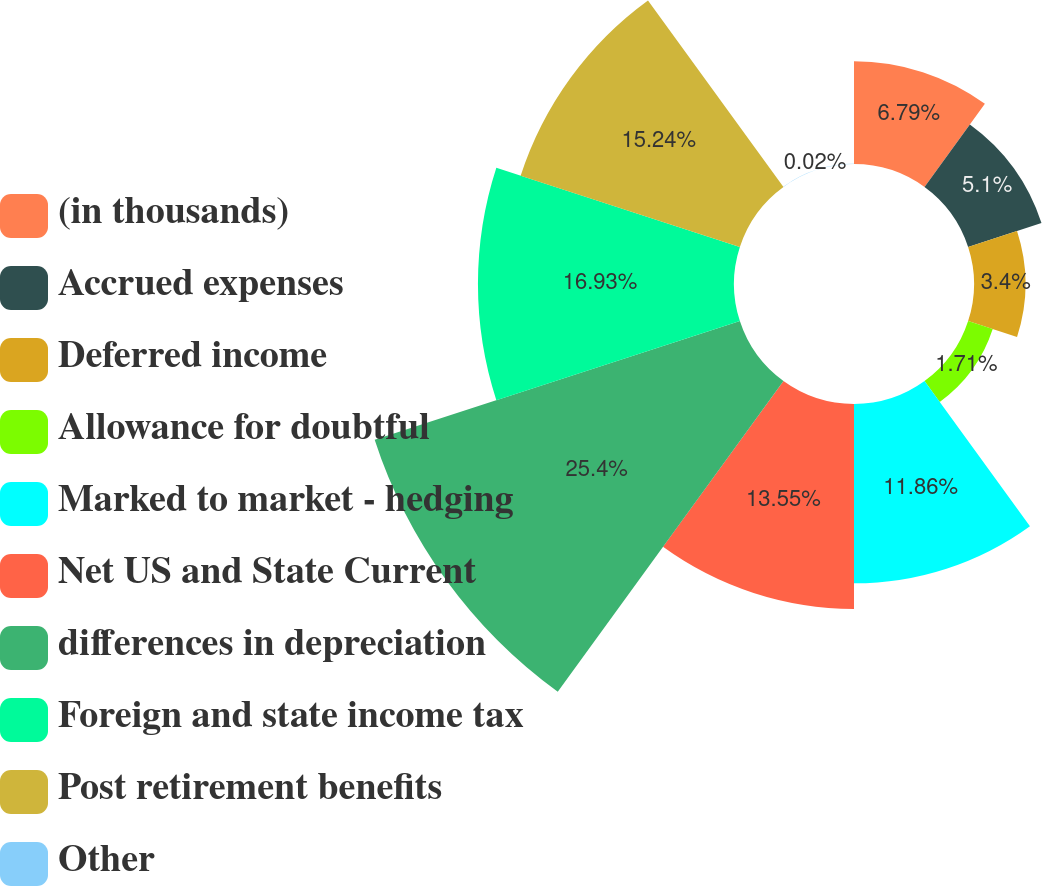Convert chart. <chart><loc_0><loc_0><loc_500><loc_500><pie_chart><fcel>(in thousands)<fcel>Accrued expenses<fcel>Deferred income<fcel>Allowance for doubtful<fcel>Marked to market - hedging<fcel>Net US and State Current<fcel>differences in depreciation<fcel>Foreign and state income tax<fcel>Post retirement benefits<fcel>Other<nl><fcel>6.79%<fcel>5.1%<fcel>3.4%<fcel>1.71%<fcel>11.86%<fcel>13.55%<fcel>25.39%<fcel>16.93%<fcel>15.24%<fcel>0.02%<nl></chart> 